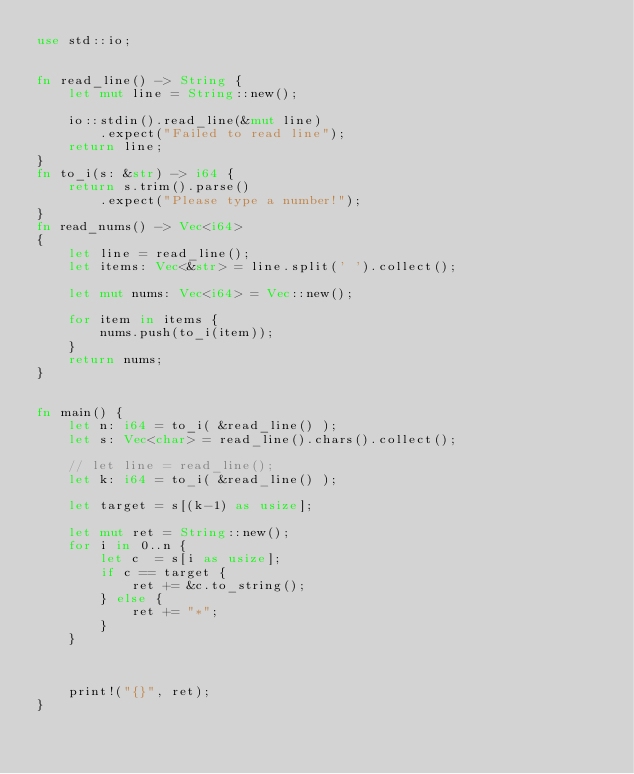Convert code to text. <code><loc_0><loc_0><loc_500><loc_500><_Rust_>use std::io;


fn read_line() -> String {
    let mut line = String::new();

    io::stdin().read_line(&mut line)
        .expect("Failed to read line");
    return line;
}
fn to_i(s: &str) -> i64 {
    return s.trim().parse()
        .expect("Please type a number!");
}
fn read_nums() -> Vec<i64>
{
    let line = read_line();
    let items: Vec<&str> = line.split(' ').collect();

    let mut nums: Vec<i64> = Vec::new();

    for item in items {
        nums.push(to_i(item));
    }
    return nums;
}


fn main() {
    let n: i64 = to_i( &read_line() );
    let s: Vec<char> = read_line().chars().collect();

    // let line = read_line();
    let k: i64 = to_i( &read_line() );

    let target = s[(k-1) as usize];

    let mut ret = String::new();
    for i in 0..n {
        let c  = s[i as usize];
        if c == target {
            ret += &c.to_string();
        } else {
            ret += "*";
        }
    }



    print!("{}", ret);
}   </code> 